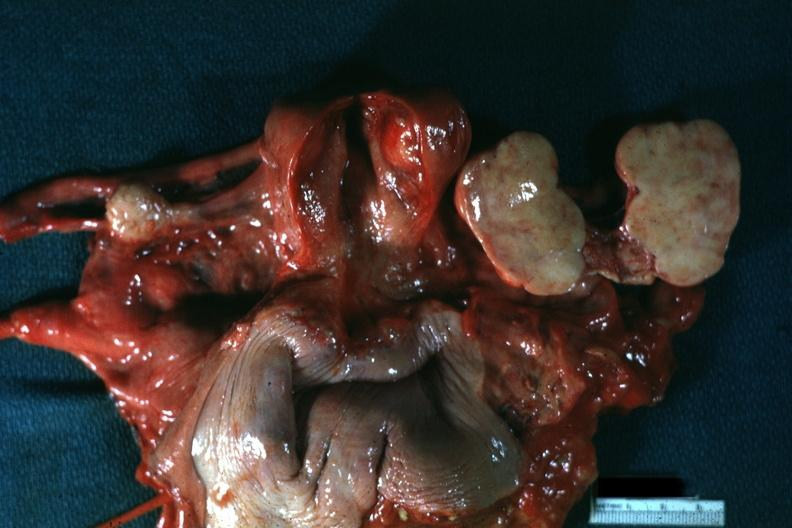what is present?
Answer the question using a single word or phrase. Female reproductive 